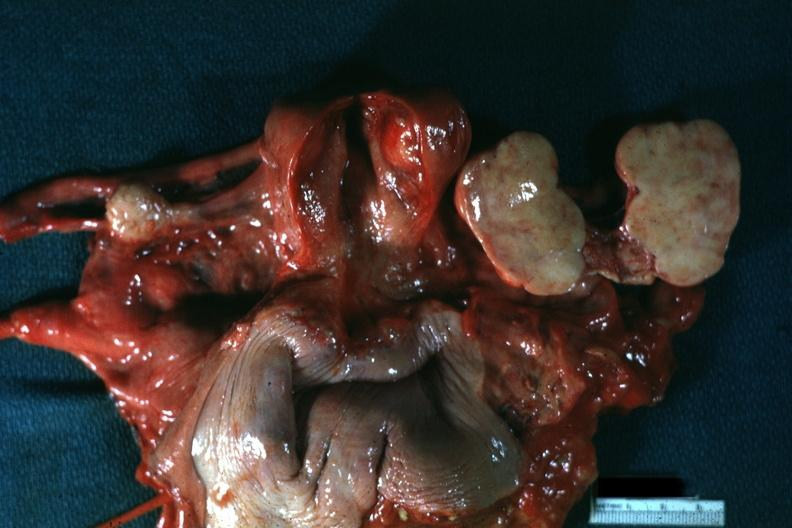what is present?
Answer the question using a single word or phrase. Female reproductive 